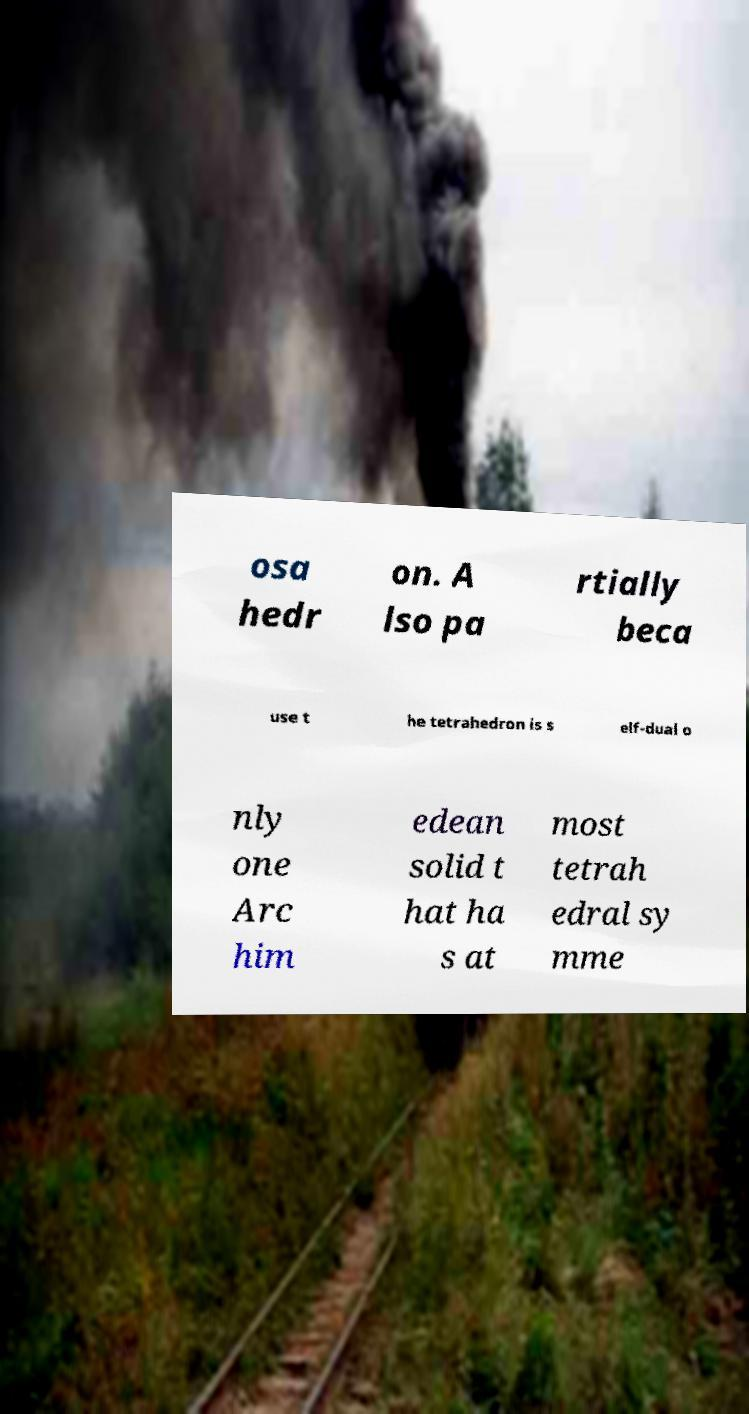Could you extract and type out the text from this image? osa hedr on. A lso pa rtially beca use t he tetrahedron is s elf-dual o nly one Arc him edean solid t hat ha s at most tetrah edral sy mme 